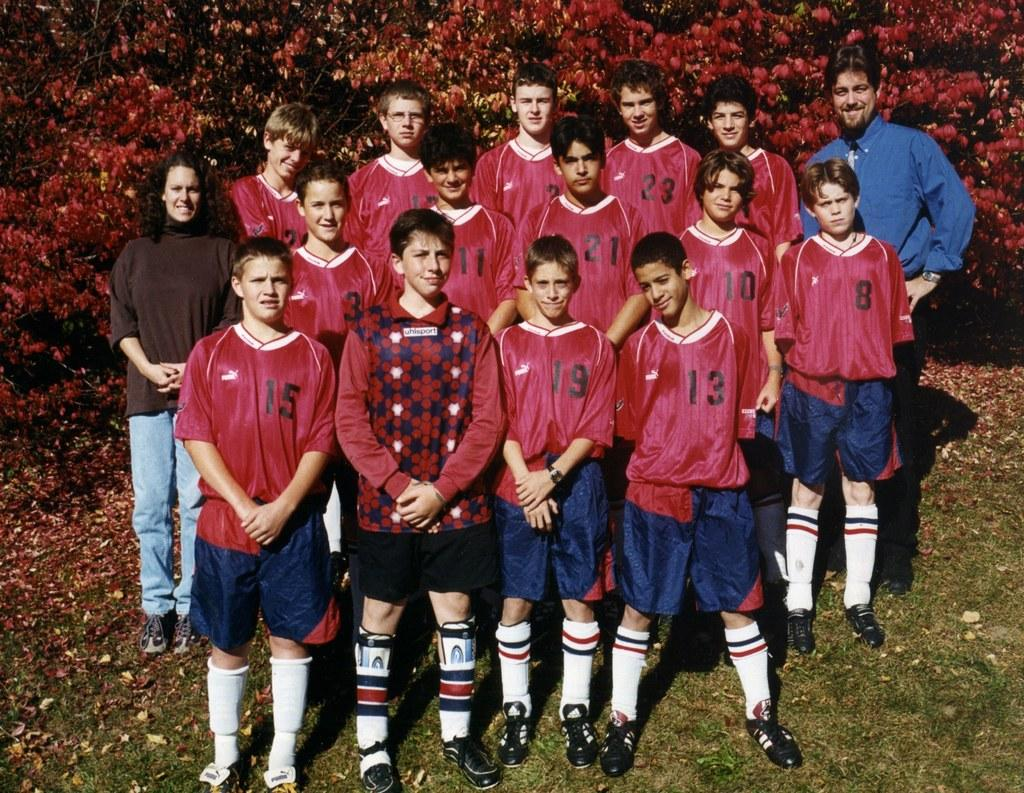What are the people in the image doing? The persons in the image are standing on the ground. What can be seen in the background of the image? There are trees in the background of the image. What is on the ground in the image? There are leaves on the ground. What type of reaction can be seen from the ghost in the image? There is no ghost present in the image, so it is not possible to determine any reaction. 